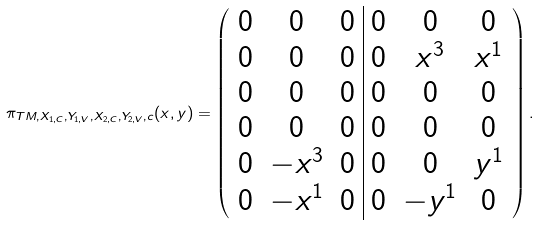<formula> <loc_0><loc_0><loc_500><loc_500>\pi _ { T M , X _ { 1 , C } , Y _ { 1 , V } , X _ { 2 , C } , Y _ { 2 , V } , c } ( { x } , { y } ) = \left ( \begin{array} { c c c | c c c } 0 & 0 & 0 & 0 & 0 & 0 \\ 0 & 0 & 0 & 0 & x ^ { 3 } & x ^ { 1 } \\ 0 & 0 & 0 & 0 & 0 & 0 \\ 0 & 0 & 0 & 0 & 0 & 0 \\ 0 & - x ^ { 3 } & 0 & 0 & 0 & y ^ { 1 } \\ 0 & - x ^ { 1 } & 0 & 0 & - y ^ { 1 } & 0 \\ \end{array} \right ) .</formula> 